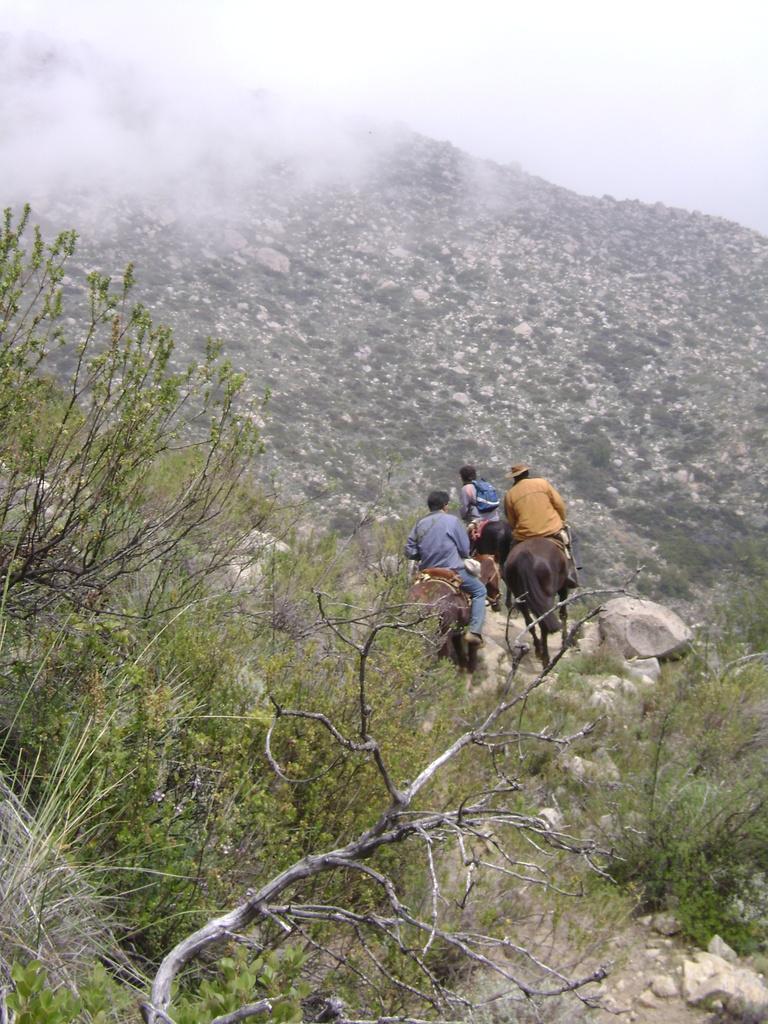In one or two sentences, can you explain what this image depicts? In this image we can see a group of people riding on a horse on the ground. In the background, we can see a group of trees, mountain and sky. 